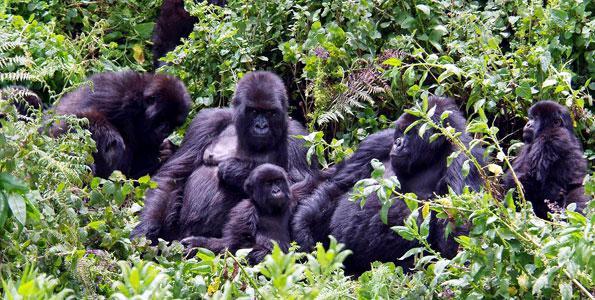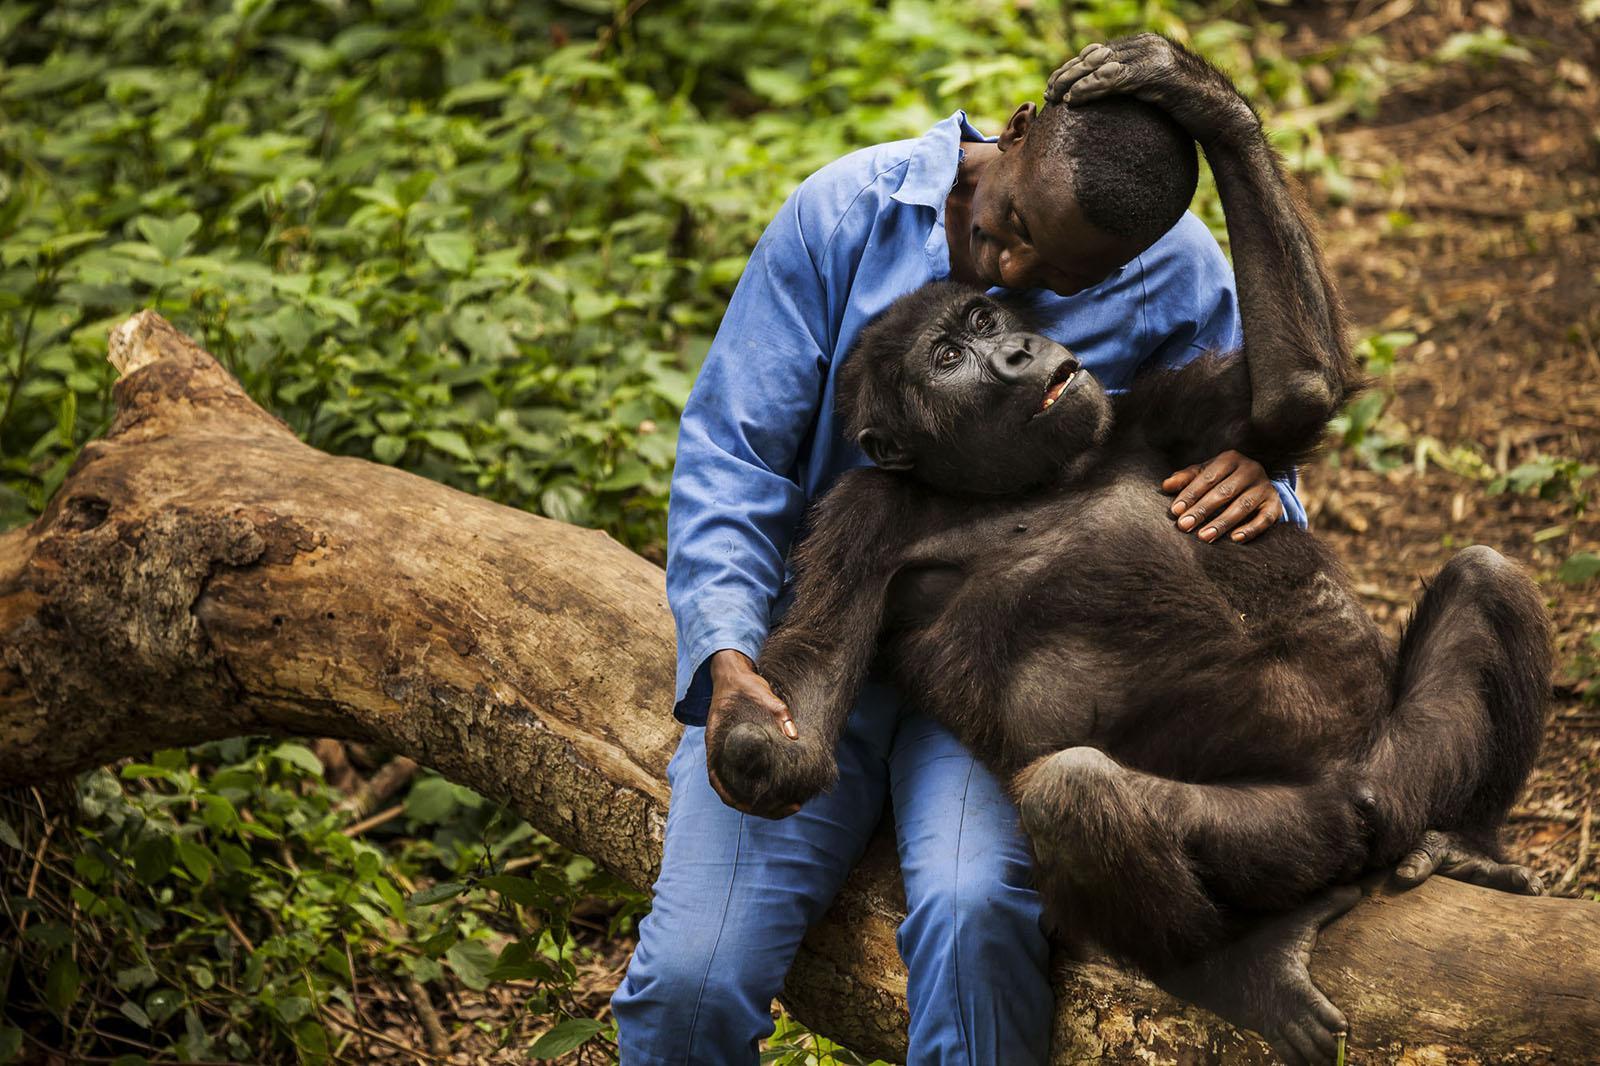The first image is the image on the left, the second image is the image on the right. For the images displayed, is the sentence "I human is interacting with an ape." factually correct? Answer yes or no. Yes. The first image is the image on the left, the second image is the image on the right. Assess this claim about the two images: "One image shows a man interacting with a gorilla, with one of them in front of the other but their bodies not facing, and the man is holding on to one of the gorilla's hands.". Correct or not? Answer yes or no. Yes. 